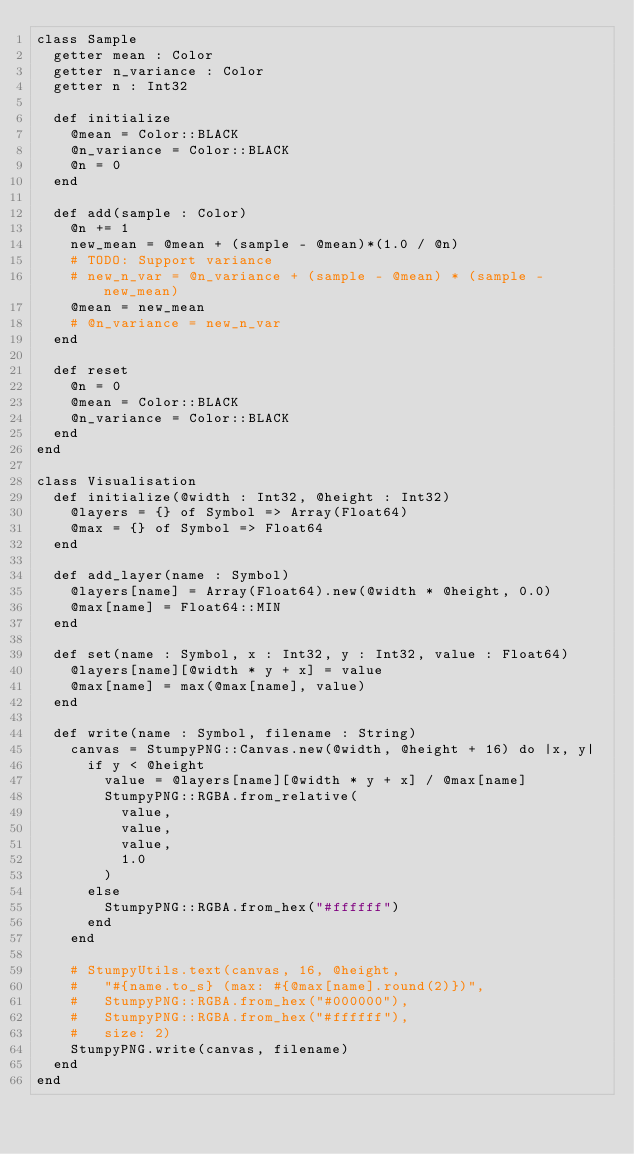<code> <loc_0><loc_0><loc_500><loc_500><_Crystal_>class Sample
  getter mean : Color
  getter n_variance : Color
  getter n : Int32

  def initialize
    @mean = Color::BLACK
    @n_variance = Color::BLACK
    @n = 0
  end

  def add(sample : Color)
    @n += 1
    new_mean = @mean + (sample - @mean)*(1.0 / @n)
    # TODO: Support variance
    # new_n_var = @n_variance + (sample - @mean) * (sample - new_mean)
    @mean = new_mean
    # @n_variance = new_n_var
  end

  def reset
    @n = 0
    @mean = Color::BLACK
    @n_variance = Color::BLACK
  end
end

class Visualisation
  def initialize(@width : Int32, @height : Int32)
    @layers = {} of Symbol => Array(Float64)
    @max = {} of Symbol => Float64
  end

  def add_layer(name : Symbol)
    @layers[name] = Array(Float64).new(@width * @height, 0.0)
    @max[name] = Float64::MIN
  end

  def set(name : Symbol, x : Int32, y : Int32, value : Float64)
    @layers[name][@width * y + x] = value
    @max[name] = max(@max[name], value)
  end

  def write(name : Symbol, filename : String)
    canvas = StumpyPNG::Canvas.new(@width, @height + 16) do |x, y|
      if y < @height
        value = @layers[name][@width * y + x] / @max[name]
        StumpyPNG::RGBA.from_relative(
          value,
          value,
          value,
          1.0
        )
      else
        StumpyPNG::RGBA.from_hex("#ffffff")
      end
    end

    # StumpyUtils.text(canvas, 16, @height,
    #   "#{name.to_s} (max: #{@max[name].round(2)})",
    #   StumpyPNG::RGBA.from_hex("#000000"),
    #   StumpyPNG::RGBA.from_hex("#ffffff"),
    #   size: 2)
    StumpyPNG.write(canvas, filename)
  end
end
</code> 